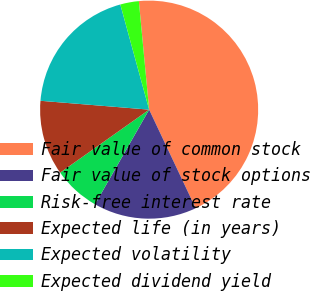Convert chart. <chart><loc_0><loc_0><loc_500><loc_500><pie_chart><fcel>Fair value of common stock<fcel>Fair value of stock options<fcel>Risk-free interest rate<fcel>Expected life (in years)<fcel>Expected volatility<fcel>Expected dividend yield<nl><fcel>44.49%<fcel>15.28%<fcel>6.93%<fcel>11.1%<fcel>19.45%<fcel>2.75%<nl></chart> 